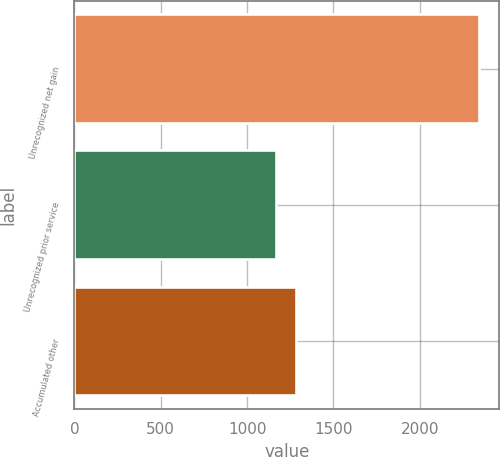Convert chart. <chart><loc_0><loc_0><loc_500><loc_500><bar_chart><fcel>Unrecognized net gain<fcel>Unrecognized prior service<fcel>Accumulated other<nl><fcel>2344<fcel>1165<fcel>1282.9<nl></chart> 